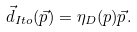Convert formula to latex. <formula><loc_0><loc_0><loc_500><loc_500>\vec { d } _ { I t o } ( \vec { p } ) = \eta _ { D } ( p ) \vec { p } .</formula> 